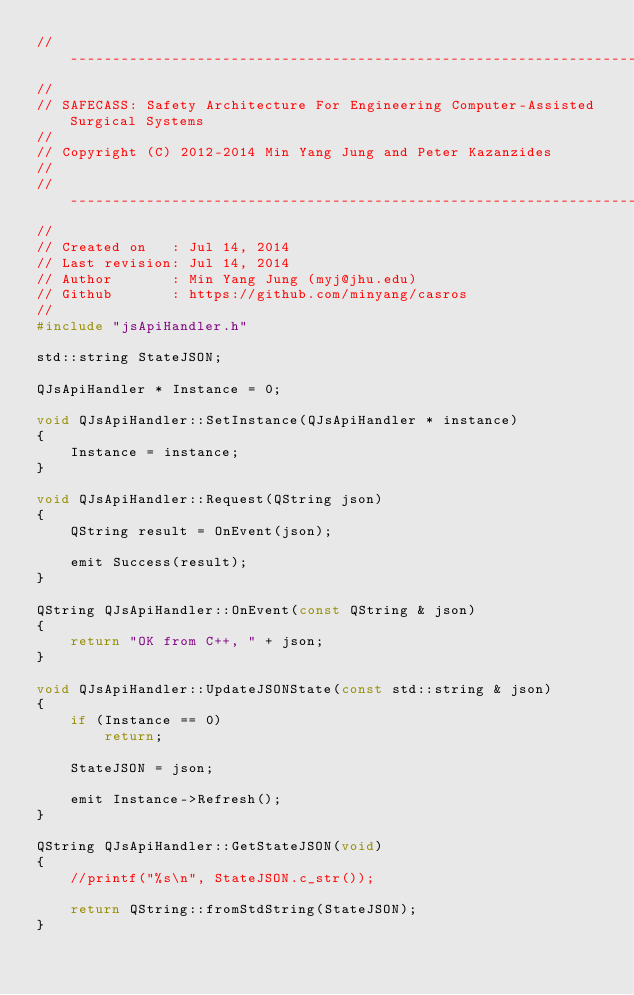Convert code to text. <code><loc_0><loc_0><loc_500><loc_500><_C++_>//------------------------------------------------------------------------
//
// SAFECASS: Safety Architecture For Engineering Computer-Assisted Surgical Systems
//
// Copyright (C) 2012-2014 Min Yang Jung and Peter Kazanzides
//
//------------------------------------------------------------------------
//
// Created on   : Jul 14, 2014
// Last revision: Jul 14, 2014
// Author       : Min Yang Jung (myj@jhu.edu)
// Github       : https://github.com/minyang/casros
//
#include "jsApiHandler.h"

std::string StateJSON;

QJsApiHandler * Instance = 0;

void QJsApiHandler::SetInstance(QJsApiHandler * instance)
{
    Instance = instance;
}

void QJsApiHandler::Request(QString json)
{
    QString result = OnEvent(json);

    emit Success(result);
}

QString QJsApiHandler::OnEvent(const QString & json)
{
    return "OK from C++, " + json;
}

void QJsApiHandler::UpdateJSONState(const std::string & json)
{
    if (Instance == 0)
        return;

    StateJSON = json;

    emit Instance->Refresh();
}

QString QJsApiHandler::GetStateJSON(void)
{
    //printf("%s\n", StateJSON.c_str());

    return QString::fromStdString(StateJSON);
}
</code> 